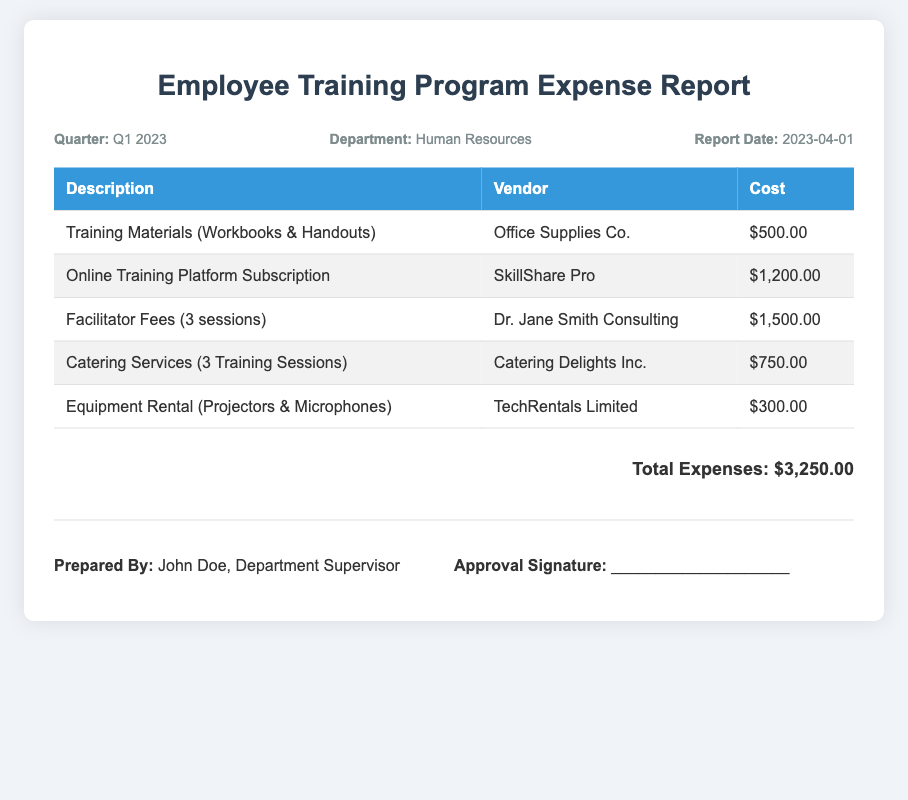What is the total expense for Q1 2023? The total expense is the cumulative amount listed in the document, which is $3,250.00.
Answer: $3,250.00 Who prepared the report? The report is prepared by John Doe, as indicated in the signature section.
Answer: John Doe What is the vendor for training materials? The vendor listed for training materials is Office Supplies Co.
Answer: Office Supplies Co How many training sessions were facilitated? The document states that there were 3 sessions facilitated by Dr. Jane Smith Consulting.
Answer: 3 sessions What is the cost of the online training platform subscription? The cost for the online training platform subscription is provided in the table, which is $1,200.00.
Answer: $1,200.00 What date was the report created? The report date is mentioned in the header section as April 1, 2023.
Answer: 2023-04-01 What type of document is this? This document is classified as an Employee Training Program Expense Report for Q1 2023.
Answer: Expense Report Which company provided catering services? Catering Delights Inc. is identified as the company that provided catering services.
Answer: Catering Delights Inc What is the cost for equipment rental? The cost for equipment rental is stated in the table as $300.00.
Answer: $300.00 